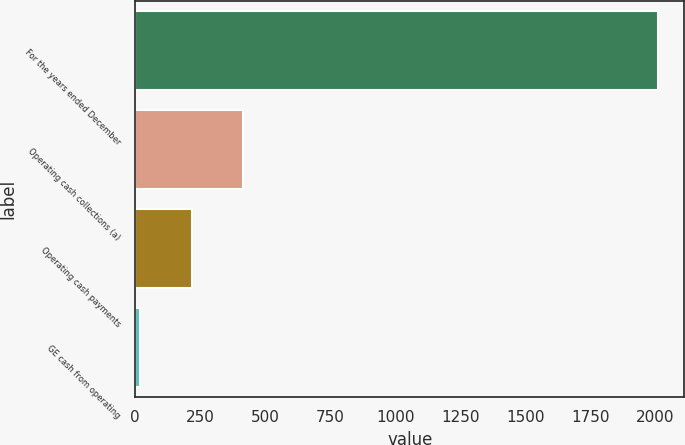Convert chart to OTSL. <chart><loc_0><loc_0><loc_500><loc_500><bar_chart><fcel>For the years ended December<fcel>Operating cash collections (a)<fcel>Operating cash payments<fcel>GE cash from operating<nl><fcel>2012<fcel>416.64<fcel>217.22<fcel>17.8<nl></chart> 